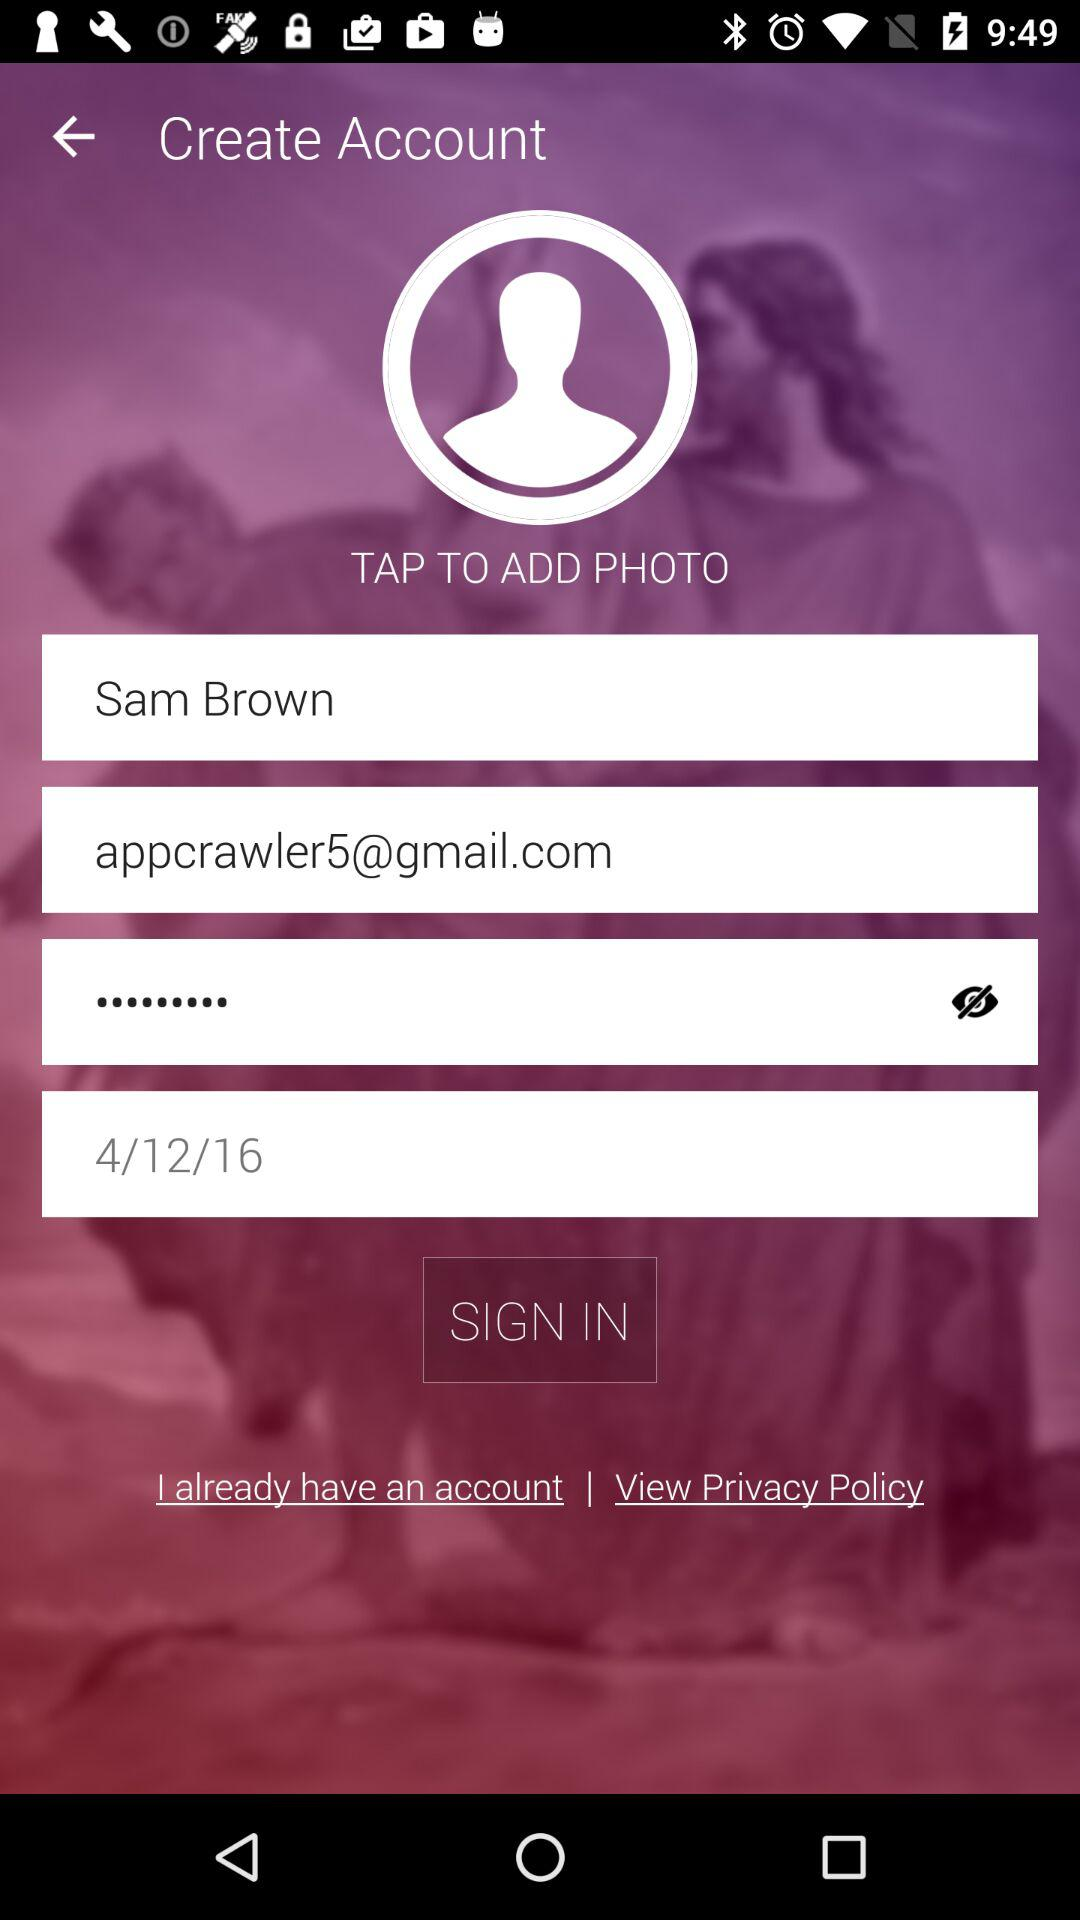What is the user name? The user name is Sam Brown. 